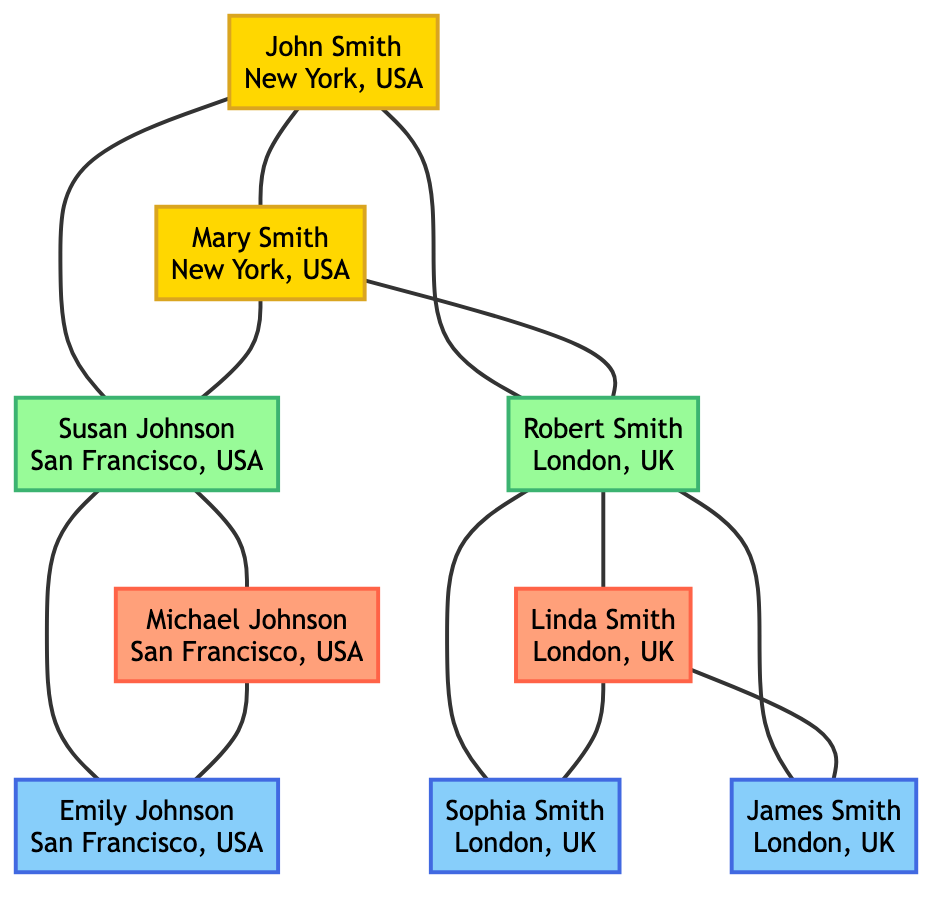What are the names of John's children? From the diagram, we can see that John Smith has two children: Susan Johnson and Robert Smith, as they are connected directly to him.
Answer: Susan Johnson, Robert Smith Where does Mary Smith live? The diagram shows that Mary Smith resides in New York, USA, as indicated next to her name.
Answer: New York, USA How many grandchildren does Robert Smith have? Robert Smith has two grandchildren: Sophia Smith and James Smith, and they are connected directly below him in the family hierarchy.
Answer: 2 Who is Susan Johnson's spouse? The diagram clearly identifies that Susan Johnson is married to Michael Johnson, as he is connected to Susan directly in the diagram.
Answer: Michael Johnson What is the location of Emily Johnson? Directly beneath her name in the diagram, it indicates that Emily Johnson lives in San Francisco, USA.
Answer: San Francisco, USA Who are the parents of Sophia Smith? Following the connections in the diagram, we can determine that Sophia Smith's parents are Robert Smith and Linda Smith, as they are linked directly to her in the family tree.
Answer: Robert Smith, Linda Smith Which grandparent lives in London, UK? The diagram shows that Robert Smith, one of the children of John and Mary Smith, lives in London, UK; thus, he is the grandparent living in this location.
Answer: Robert Smith How many family members are listed under Susan Johnson? Counting the members connected directly under Susan Johnson in the diagram, we see her husband Michael and their child Emily, totaling three family members (Susan, Michael, and Emily).
Answer: 3 